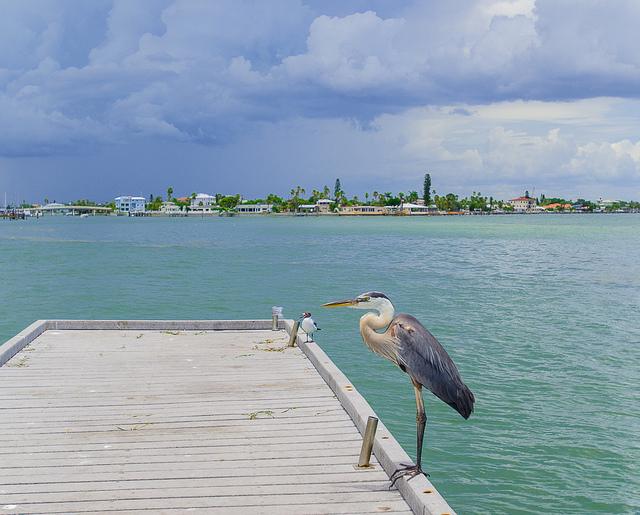What type of bird is this?
Be succinct. Pelican. What are the birds standing on?
Be succinct. Dock. How many birds are standing on the dock?
Concise answer only. 2. 